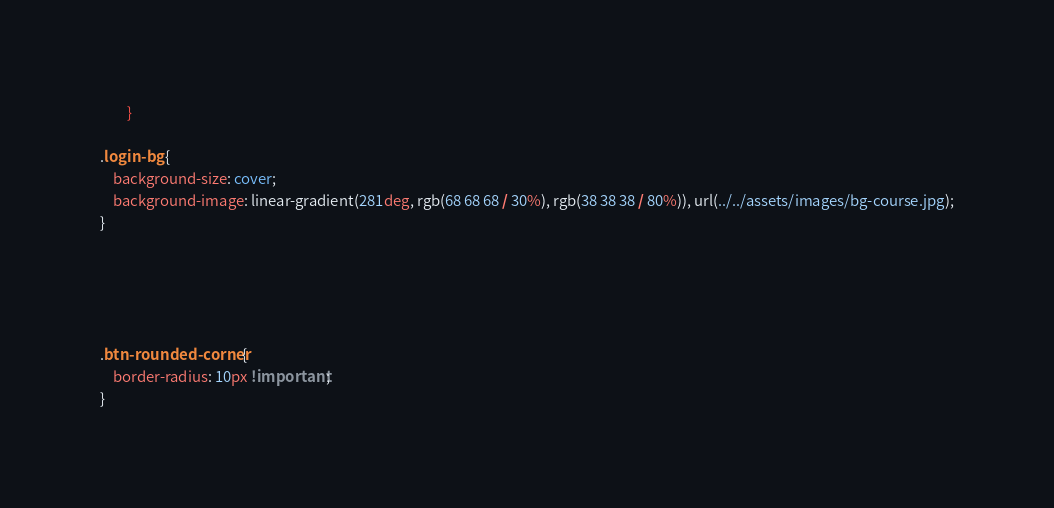<code> <loc_0><loc_0><loc_500><loc_500><_CSS_>		}

.login-bg {
	background-size: cover;
    background-image: linear-gradient(281deg, rgb(68 68 68 / 30%), rgb(38 38 38 / 80%)), url(../../assets/images/bg-course.jpg);
}





.btn-rounded-corner{
    border-radius: 10px !important;
}</code> 